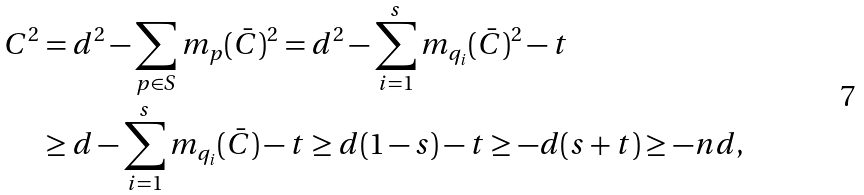Convert formula to latex. <formula><loc_0><loc_0><loc_500><loc_500>C ^ { 2 } & = d ^ { 2 } - \sum _ { p \in S } m _ { p } ( \bar { C } ) ^ { 2 } = d ^ { 2 } - \sum _ { i = 1 } ^ { s } m _ { q _ { i } } ( \bar { C } ) ^ { 2 } - t \\ & \geq d - \sum _ { i = 1 } ^ { s } m _ { q _ { i } } ( \bar { C } ) - t \geq d ( 1 - s ) - t \geq - d ( s + t ) \geq - n d ,</formula> 